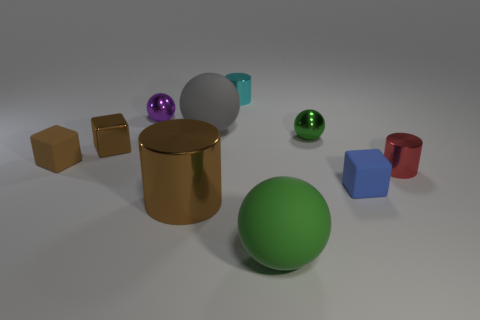What size is the rubber cube that is the same color as the metal block?
Your answer should be very brief. Small. The other shiny object that is the same color as the big metal object is what shape?
Give a very brief answer. Cube. Is the number of tiny green shiny spheres right of the tiny green ball the same as the number of small objects behind the large gray rubber sphere?
Your answer should be compact. No. What color is the other large object that is the same shape as the large green rubber thing?
Keep it short and to the point. Gray. Is there any other thing that has the same color as the small metallic block?
Ensure brevity in your answer.  Yes. What number of metal objects are either tiny green things or cylinders?
Provide a short and direct response. 4. Do the big cylinder and the tiny metallic block have the same color?
Offer a terse response. Yes. Are there more small balls that are behind the small cyan cylinder than purple metal balls?
Offer a terse response. No. What number of other objects are the same material as the purple object?
Provide a short and direct response. 5. How many tiny things are either metallic blocks or blue metal things?
Your answer should be compact. 1. 